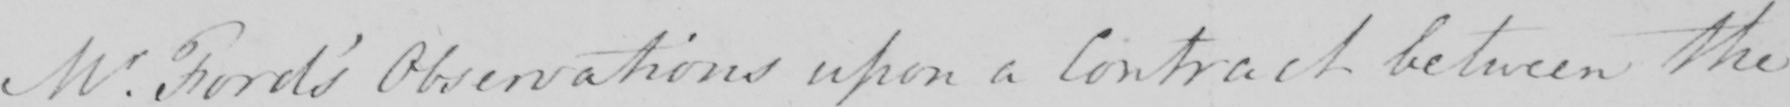What text is written in this handwritten line? Mr . Ford ' s Observations upon a Contract between the 